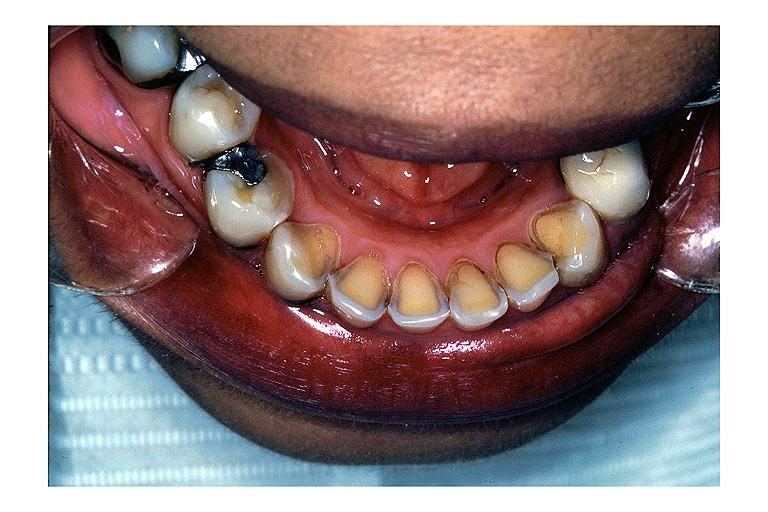does this image show erosion?
Answer the question using a single word or phrase. Yes 